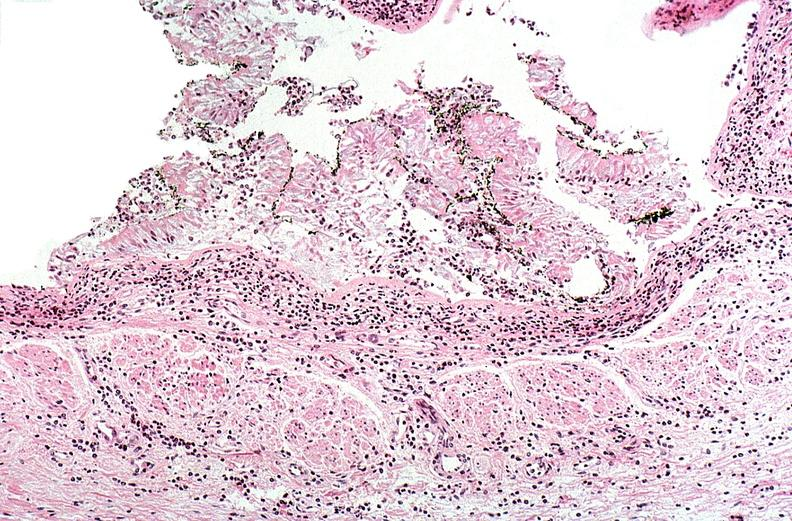what is present?
Answer the question using a single word or phrase. Respiratory 